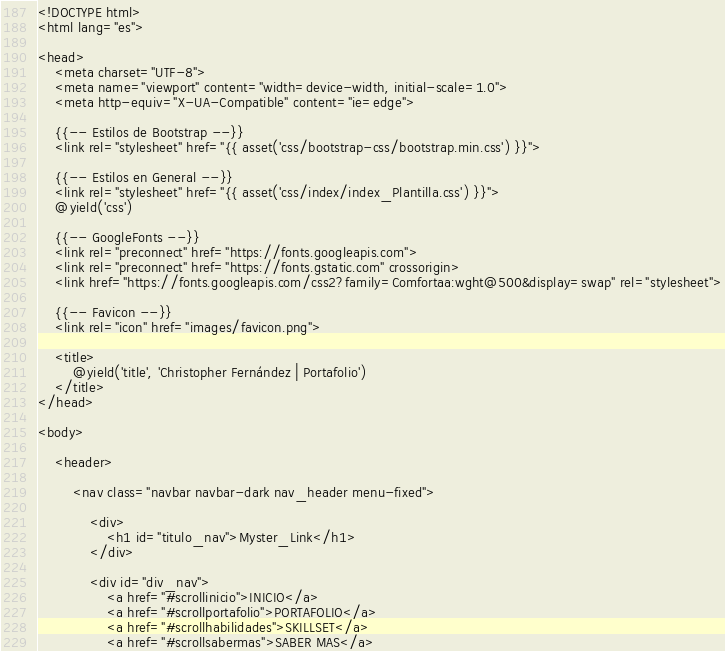<code> <loc_0><loc_0><loc_500><loc_500><_PHP_><!DOCTYPE html>
<html lang="es">

<head>
    <meta charset="UTF-8">
    <meta name="viewport" content="width=device-width, initial-scale=1.0">
    <meta http-equiv="X-UA-Compatible" content="ie=edge">

    {{-- Estilos de Bootstrap --}}
    <link rel="stylesheet" href="{{ asset('css/bootstrap-css/bootstrap.min.css') }}">

    {{-- Estilos en General --}}
    <link rel="stylesheet" href="{{ asset('css/index/index_Plantilla.css') }}">
    @yield('css')

    {{-- GoogleFonts --}}
    <link rel="preconnect" href="https://fonts.googleapis.com">
    <link rel="preconnect" href="https://fonts.gstatic.com" crossorigin>
    <link href="https://fonts.googleapis.com/css2?family=Comfortaa:wght@500&display=swap" rel="stylesheet">

    {{-- Favicon --}}
    <link rel="icon" href="images/favicon.png">

    <title>
        @yield('title', 'Christopher Fernández | Portafolio')
    </title>
</head>

<body>

    <header>

        <nav class="navbar navbar-dark nav_header menu-fixed">

            <div>
                <h1 id="titulo_nav">Myster_Link</h1>
            </div>

            <div id="div_nav">
                <a href="#scrollinicio">INICIO</a>
                <a href="#scrollportafolio">PORTAFOLIO</a>
                <a href="#scrollhabilidades">SKILLSET</a>
                <a href="#scrollsabermas">SABER MAS</a></code> 